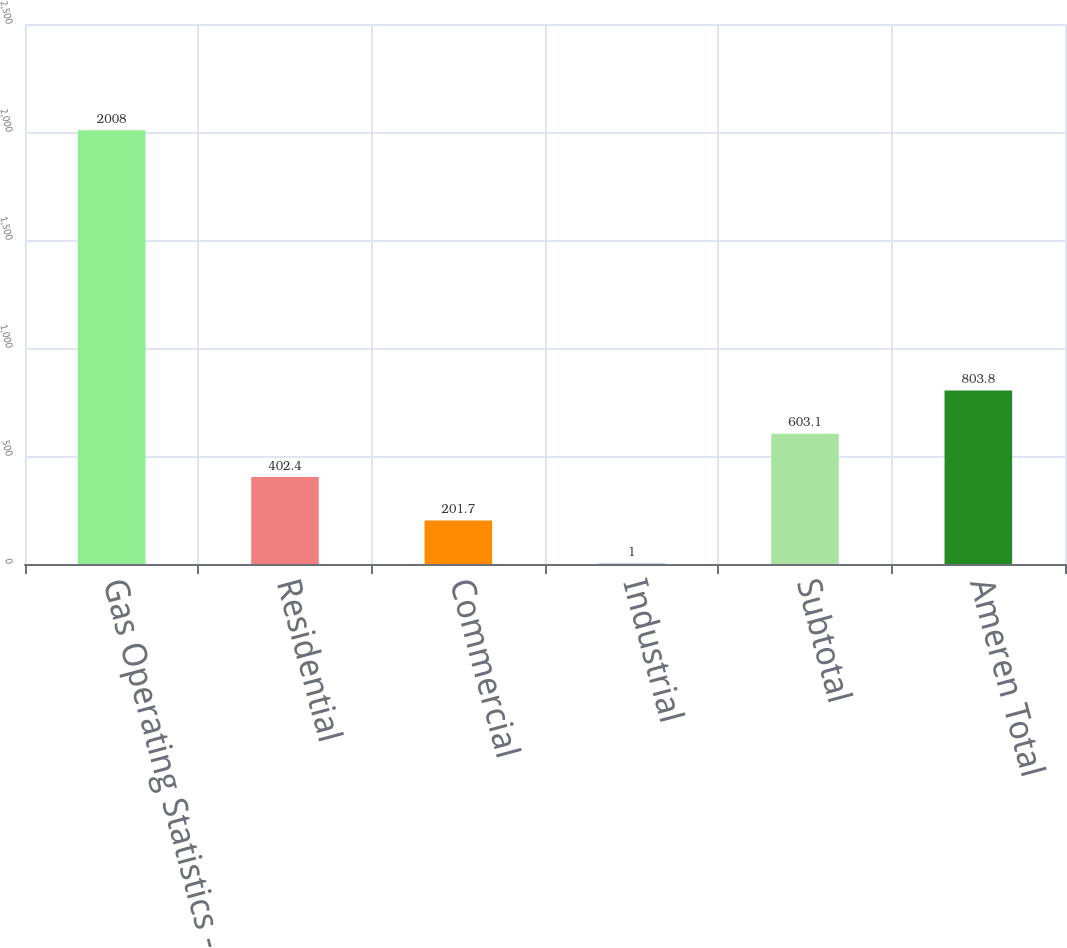Convert chart to OTSL. <chart><loc_0><loc_0><loc_500><loc_500><bar_chart><fcel>Gas Operating Statistics -<fcel>Residential<fcel>Commercial<fcel>Industrial<fcel>Subtotal<fcel>Ameren Total<nl><fcel>2008<fcel>402.4<fcel>201.7<fcel>1<fcel>603.1<fcel>803.8<nl></chart> 